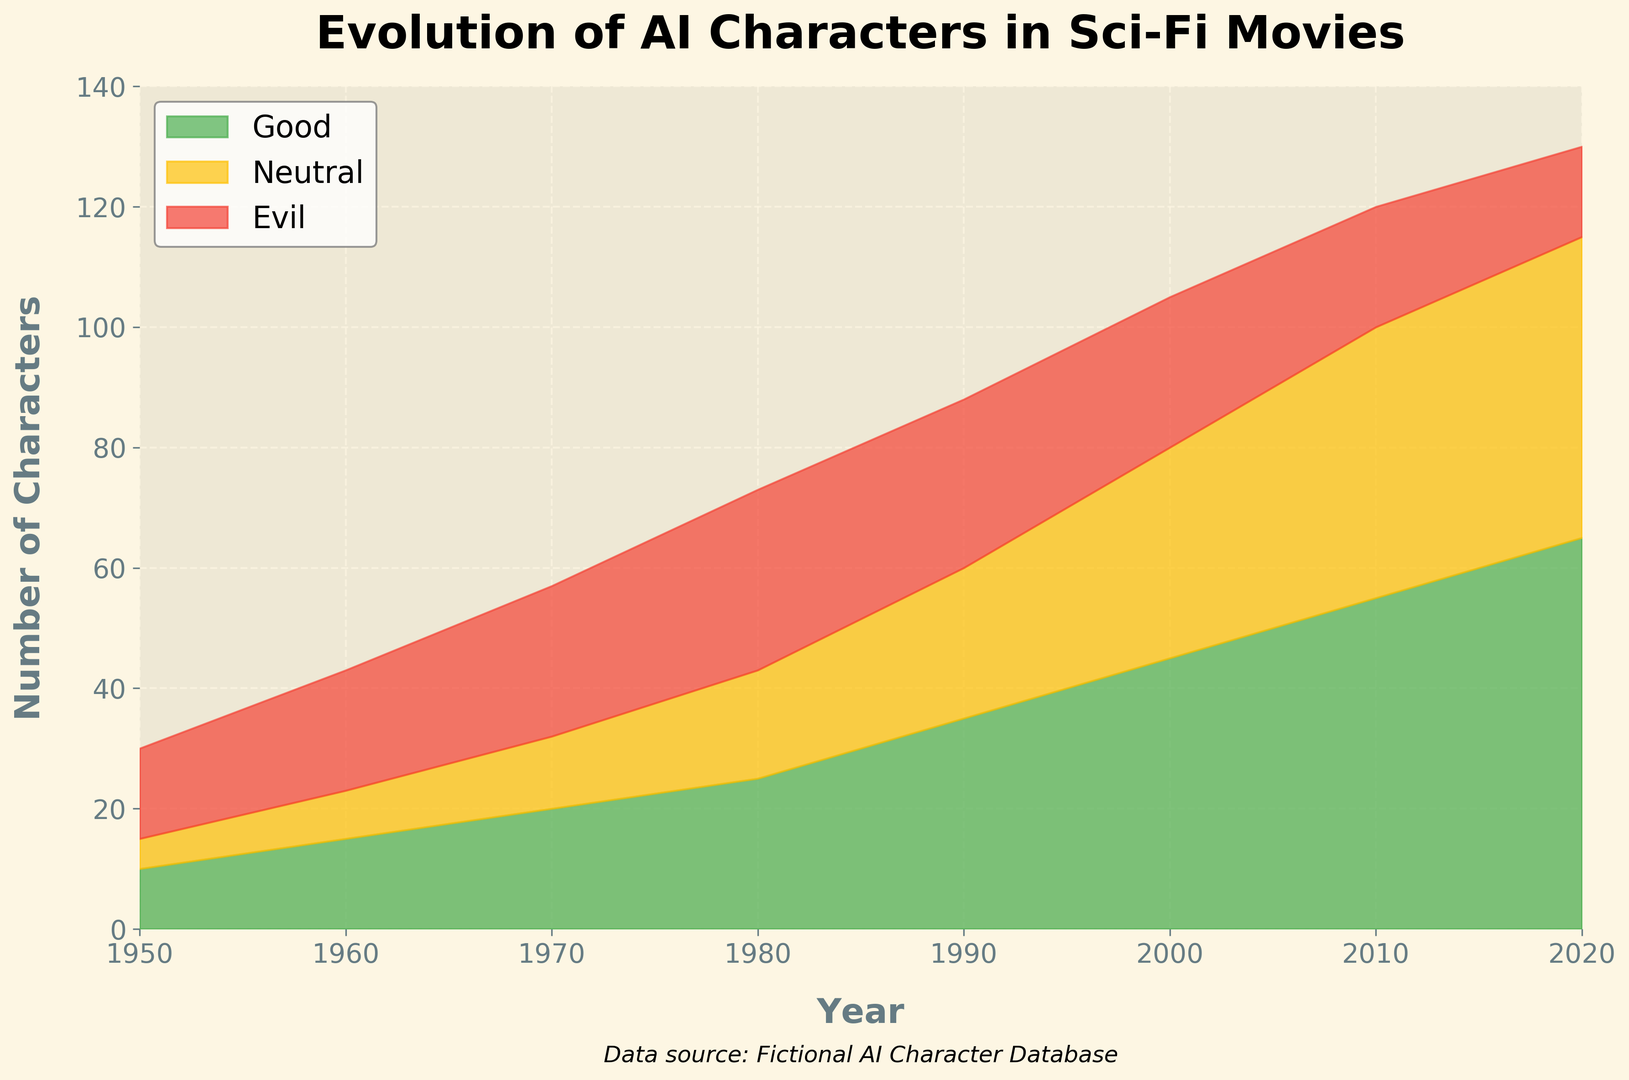What is the total number of AI characters in 1980? To find the total number of AI characters in 1980, sum the numbers of Good, Neutral, and Evil characters for that year. So, 25 (Good) + 18 (Neutral) + 30 (Evil) = 73.
Answer: 73 How does the number of Evil AI characters change from 1950 to 2020? Observe the values for the Evil category in 1950 and 2020. In 1950, there are 15 Evil characters, and in 2020, there are 15 Evil characters. Thus, the number of Evil AI characters remained constant over this period.
Answer: Constant In which decade did Good AI characters surpass Neutral AI characters? Look at the values for Good and Neutral AI characters over the decades. In 1980, Good characters are 25, and Neutral characters are 18. Before that, Good and Neutral characters were equal or Good was lower.
Answer: 1980s What is the difference in the number of Good and Evil AI characters in 2010? Subtract the number of Evil AI characters from the number of Good AI characters in 2010. 55 (Good) - 20 (Evil) = 35.
Answer: 35 Which alignment has the smallest number of AI characters in 2000? Compare the numbers for Good, Neutral, and Evil AI characters in 2000. Evil has 25 characters, which is the smallest compared to 45 (Good) and 35 (Neutral).
Answer: Evil What is the sum of Good and Neutral AI characters in 1960? Add the number of Good and Neutral AI characters in 1960. So, 15 (Good) + 8 (Neutral) = 23.
Answer: 23 How did the proportion of Good AI characters change from 1950 to 2020? Compare the relative proportion of Good AI characters in the overall total from 1950 to 2020. In 1950, Good characters are 10 out of 30 (10/30 = 33.3%), and in 2020, they are 65 out of 130 (65/130 ≈ 50%). So, the proportion increased.
Answer: Increased 